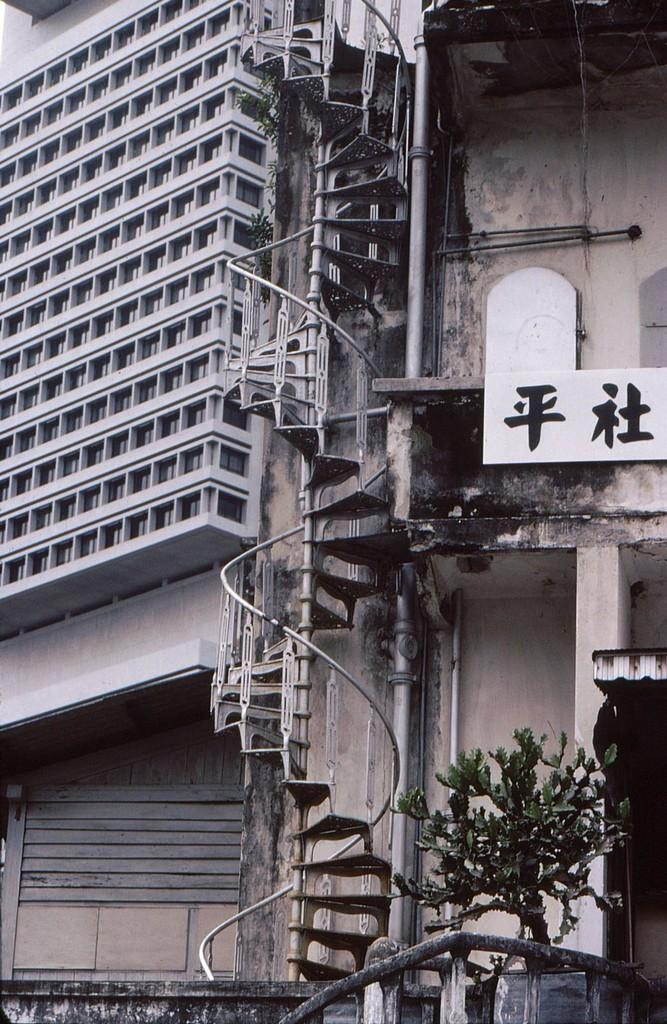What is the main subject in the middle of the image? There are steps of a building in the middle of the image. What can be seen on the right side of the image? There is a plant on the right side of the image. What is visible in the background of the image? There is a building with windows in the background of the image. What type of cracker is being distributed to the crowd in the image? There is no crowd or cracker present in the image. 